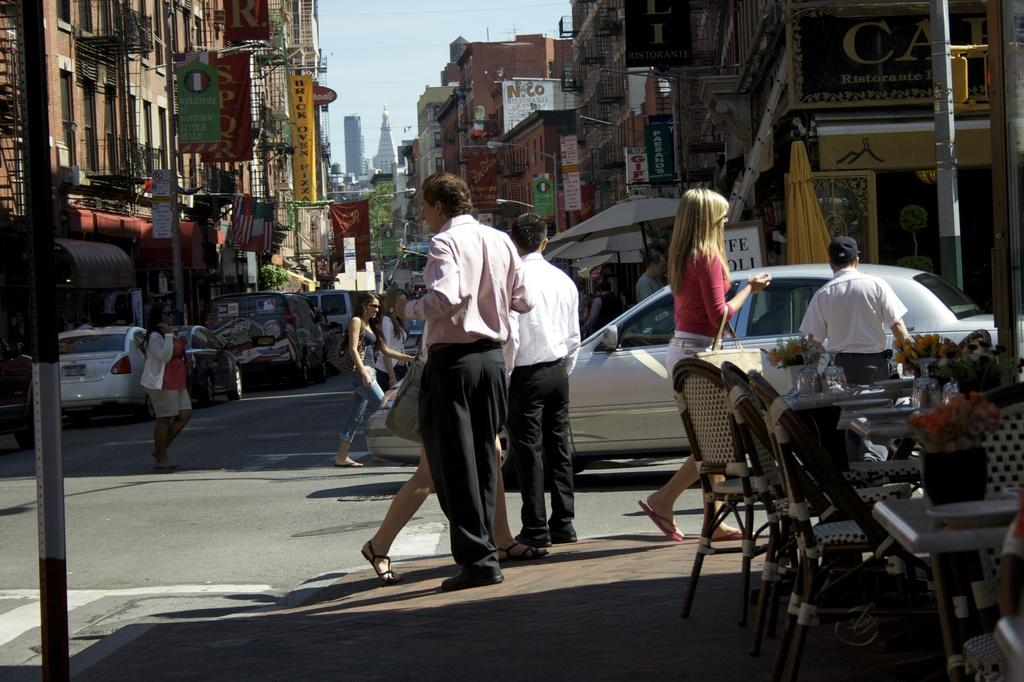What are the people in the image doing? The people in the image are walking across the street. What else can be seen in the image besides the people? There are parked vehicles in the image. Can you tell me how many kittens are playing in the stream in the image? There is no stream or kittens present in the image. 